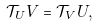<formula> <loc_0><loc_0><loc_500><loc_500>\mathcal { T } _ { U } V = \mathcal { T } _ { V } U ,</formula> 